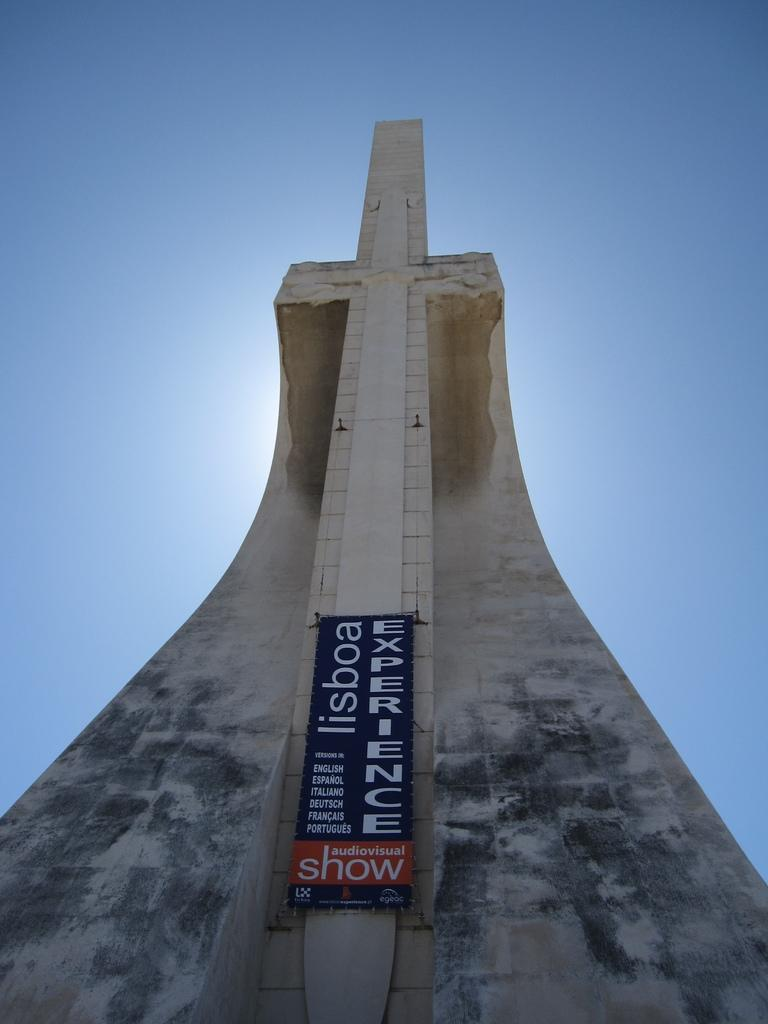What is the main structure in the center of the image? There is a tower in the center of the image. What else can be seen in the image besides the tower? There is a board in the image. What can be seen in the background of the image? The sky is visible in the background of the image. How many roses are on the board in the image? There are no roses present in the image; the board is the only item mentioned besides the tower. 